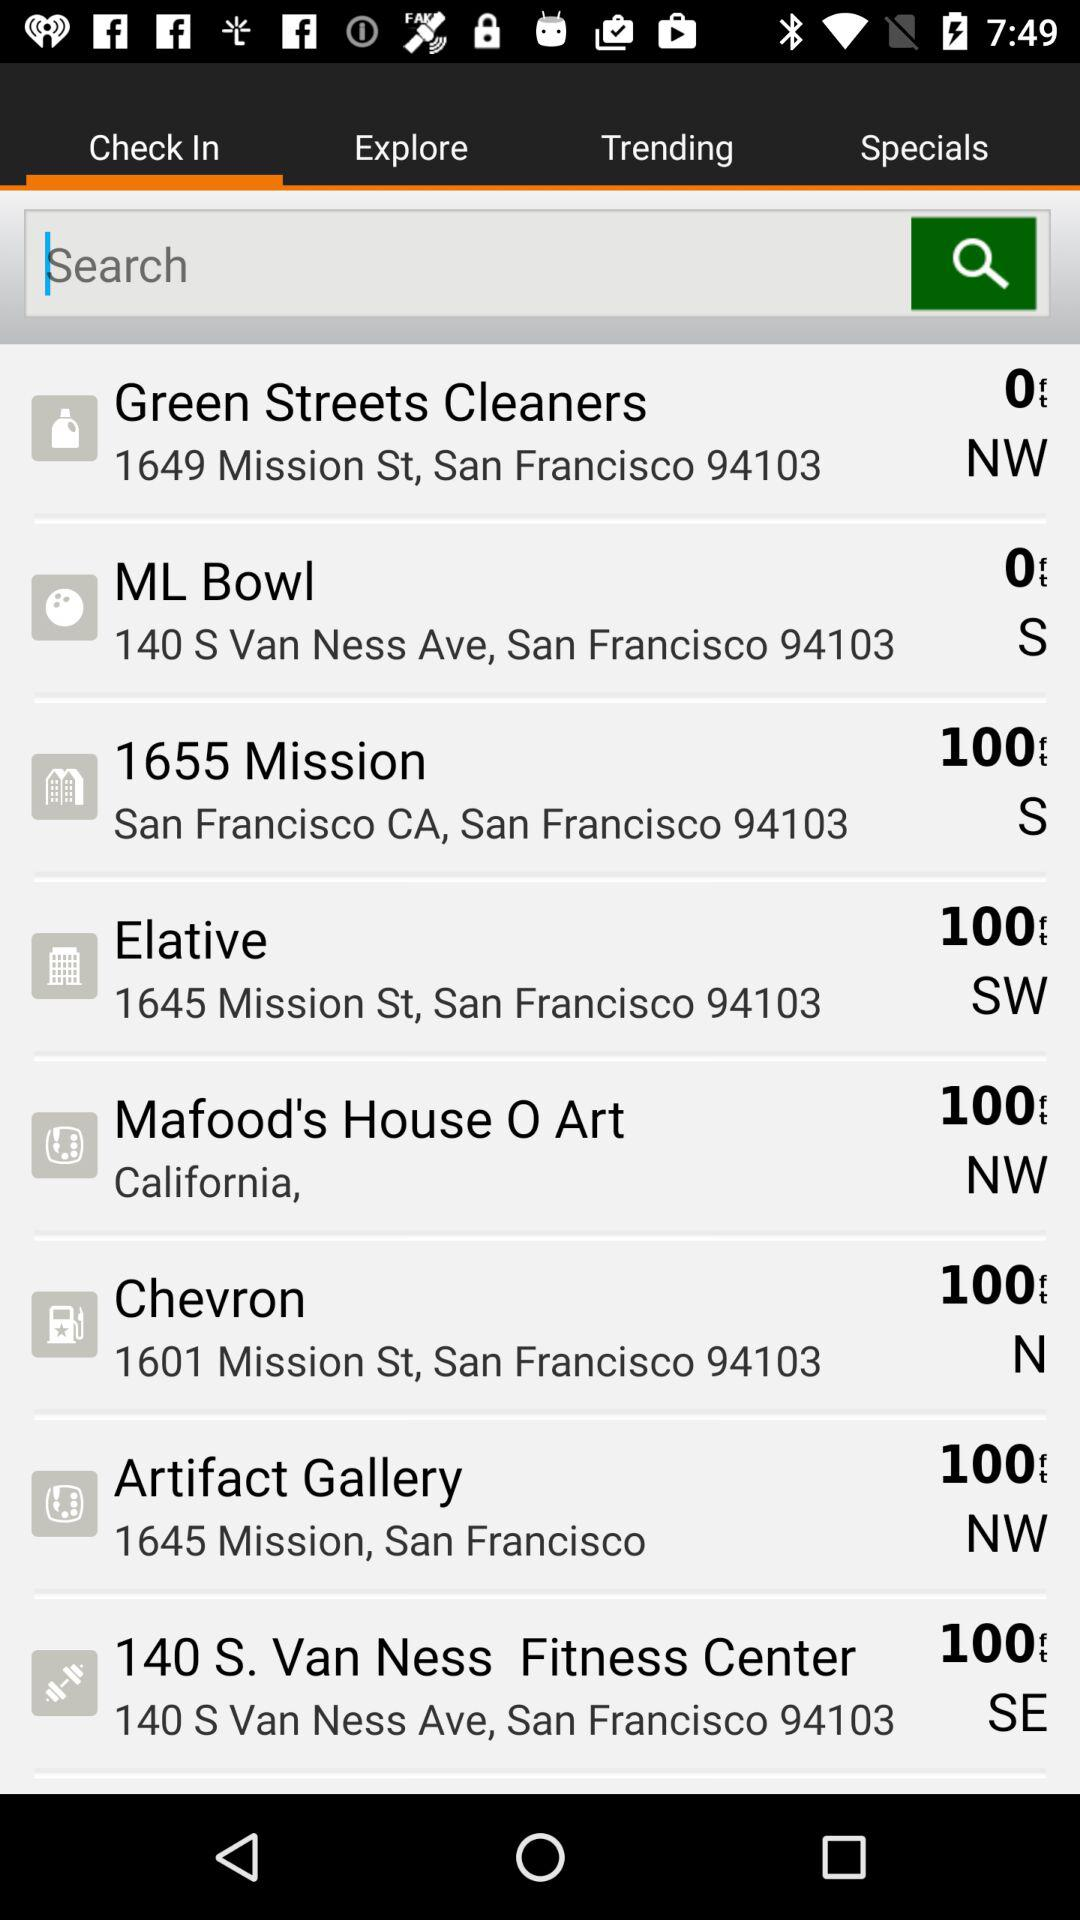Which tab is currently selected? The selected tab is "Check In". 